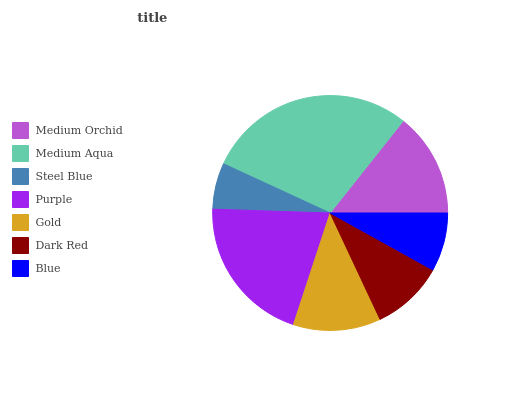Is Steel Blue the minimum?
Answer yes or no. Yes. Is Medium Aqua the maximum?
Answer yes or no. Yes. Is Medium Aqua the minimum?
Answer yes or no. No. Is Steel Blue the maximum?
Answer yes or no. No. Is Medium Aqua greater than Steel Blue?
Answer yes or no. Yes. Is Steel Blue less than Medium Aqua?
Answer yes or no. Yes. Is Steel Blue greater than Medium Aqua?
Answer yes or no. No. Is Medium Aqua less than Steel Blue?
Answer yes or no. No. Is Gold the high median?
Answer yes or no. Yes. Is Gold the low median?
Answer yes or no. Yes. Is Blue the high median?
Answer yes or no. No. Is Blue the low median?
Answer yes or no. No. 